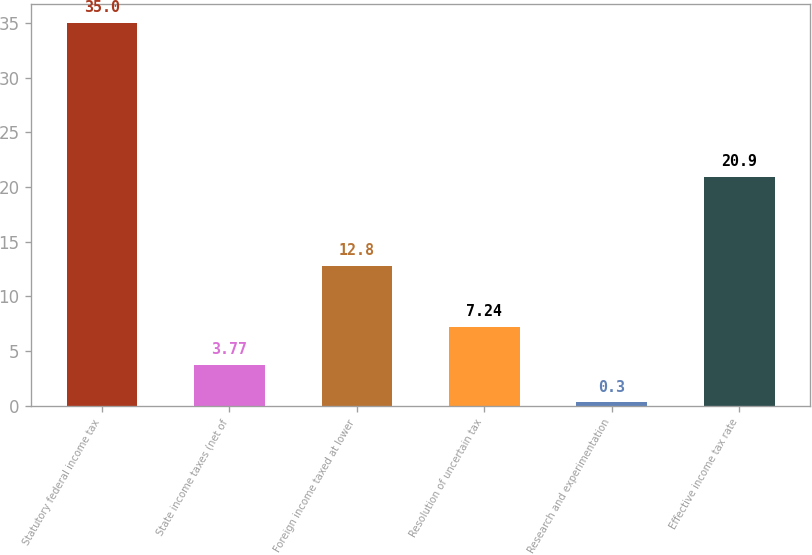<chart> <loc_0><loc_0><loc_500><loc_500><bar_chart><fcel>Statutory federal income tax<fcel>State income taxes (net of<fcel>Foreign income taxed at lower<fcel>Resolution of uncertain tax<fcel>Research and experimentation<fcel>Effective income tax rate<nl><fcel>35<fcel>3.77<fcel>12.8<fcel>7.24<fcel>0.3<fcel>20.9<nl></chart> 